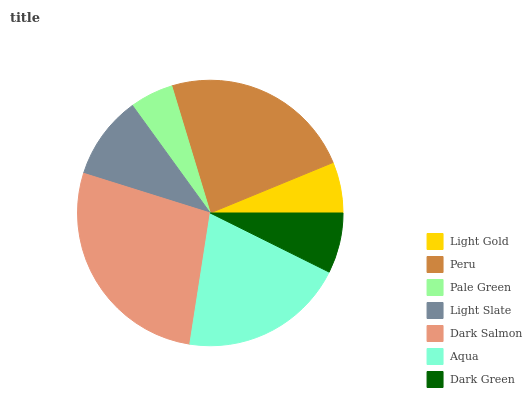Is Pale Green the minimum?
Answer yes or no. Yes. Is Dark Salmon the maximum?
Answer yes or no. Yes. Is Peru the minimum?
Answer yes or no. No. Is Peru the maximum?
Answer yes or no. No. Is Peru greater than Light Gold?
Answer yes or no. Yes. Is Light Gold less than Peru?
Answer yes or no. Yes. Is Light Gold greater than Peru?
Answer yes or no. No. Is Peru less than Light Gold?
Answer yes or no. No. Is Light Slate the high median?
Answer yes or no. Yes. Is Light Slate the low median?
Answer yes or no. Yes. Is Dark Salmon the high median?
Answer yes or no. No. Is Peru the low median?
Answer yes or no. No. 